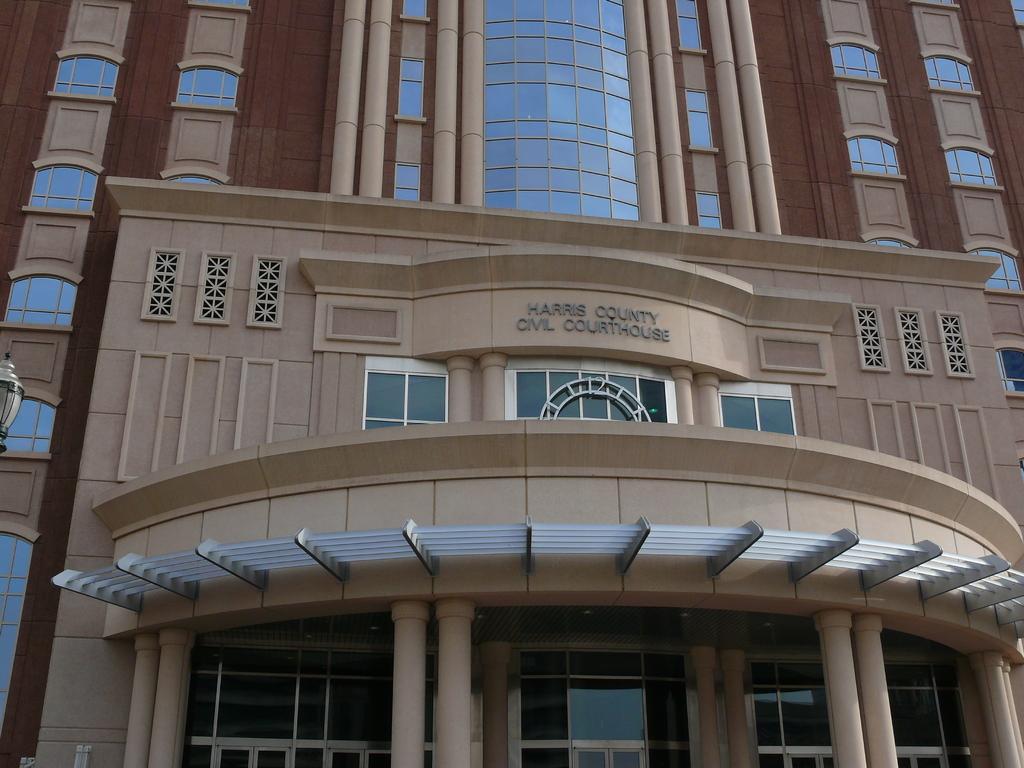In one or two sentences, can you explain what this image depicts? In this image we can see a building, there are windows, pillars, also we can see some text on the wall. 